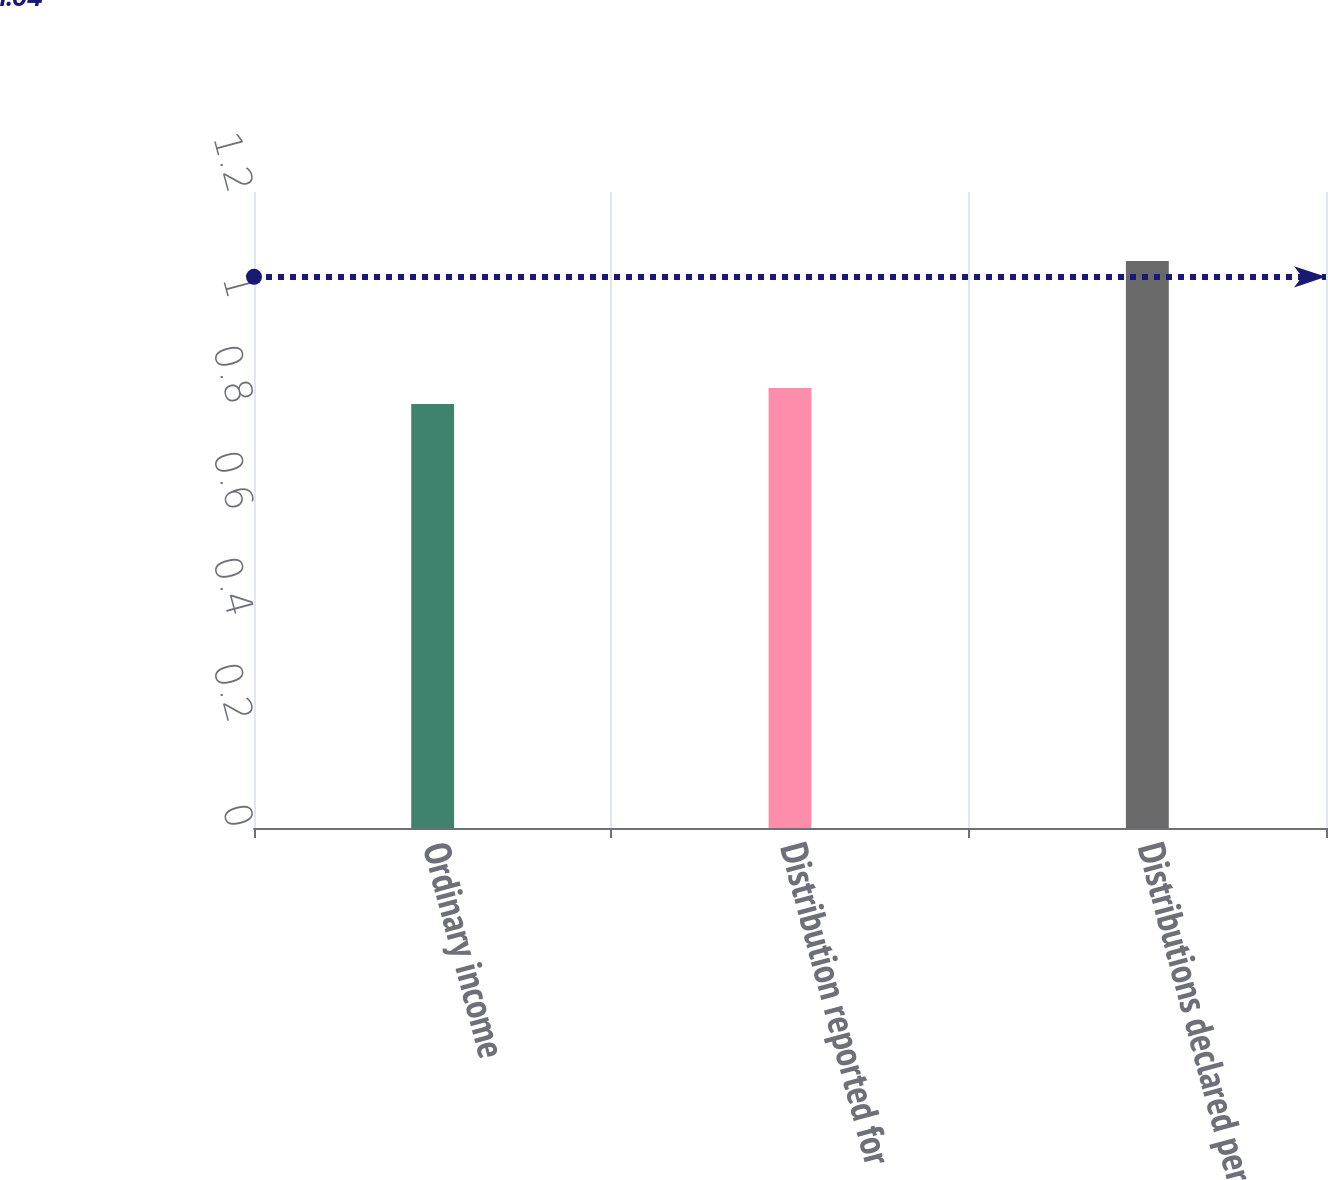Convert chart. <chart><loc_0><loc_0><loc_500><loc_500><bar_chart><fcel>Ordinary income<fcel>Distribution reported for<fcel>Distributions declared per<nl><fcel>0.8<fcel>0.83<fcel>1.07<nl></chart> 